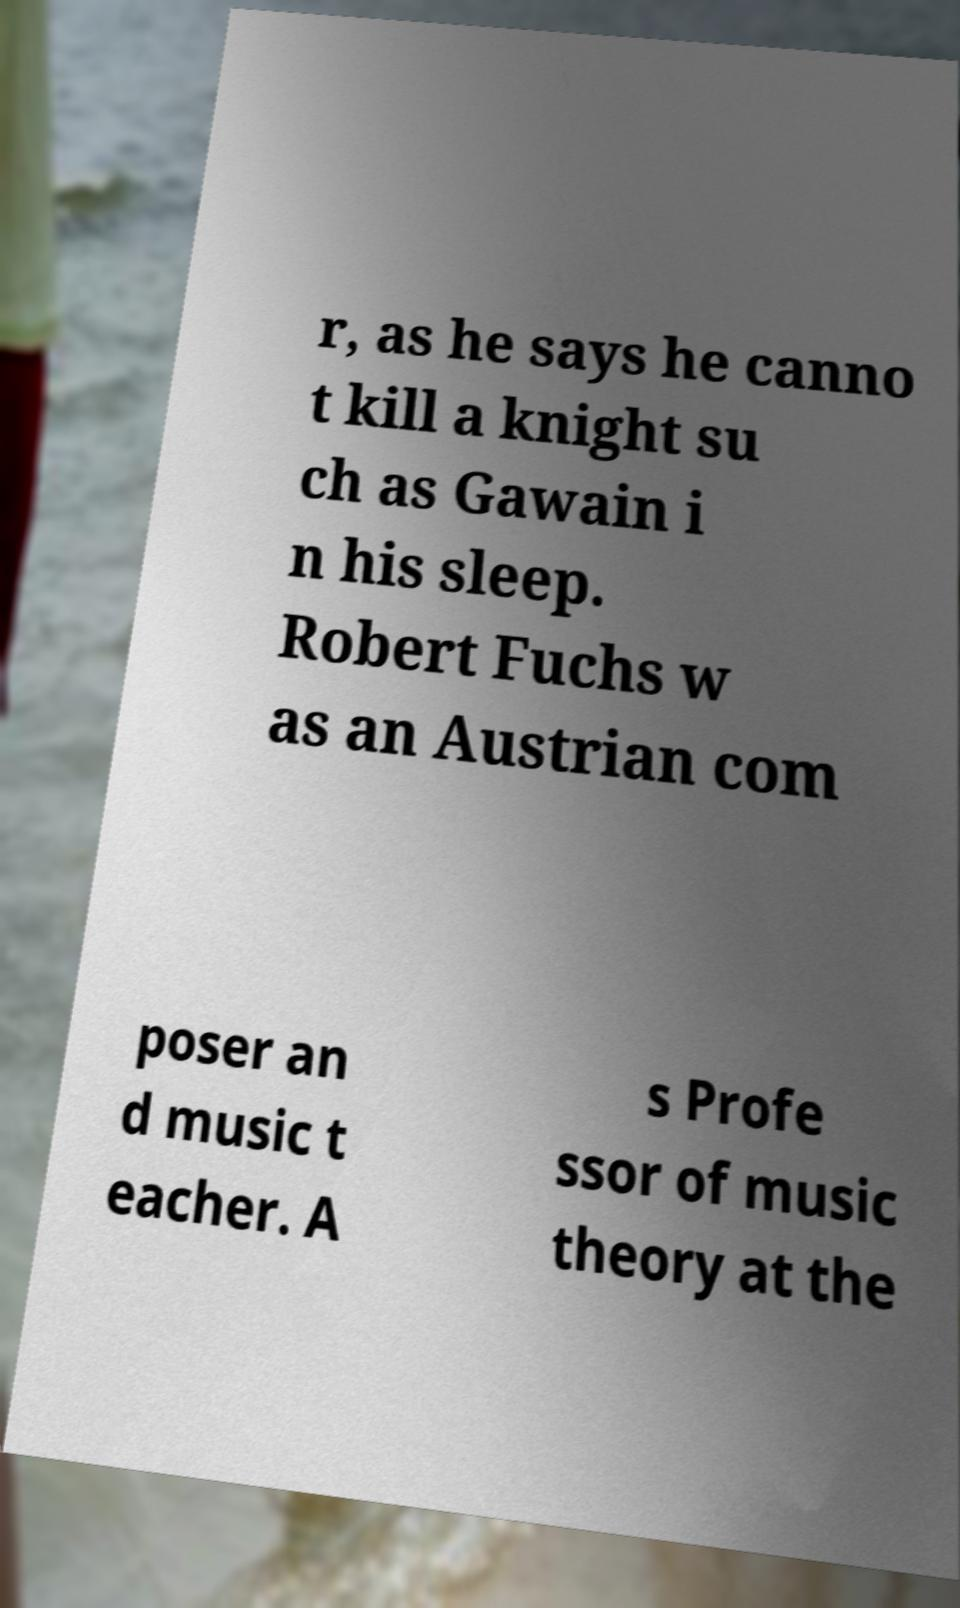Please identify and transcribe the text found in this image. r, as he says he canno t kill a knight su ch as Gawain i n his sleep. Robert Fuchs w as an Austrian com poser an d music t eacher. A s Profe ssor of music theory at the 